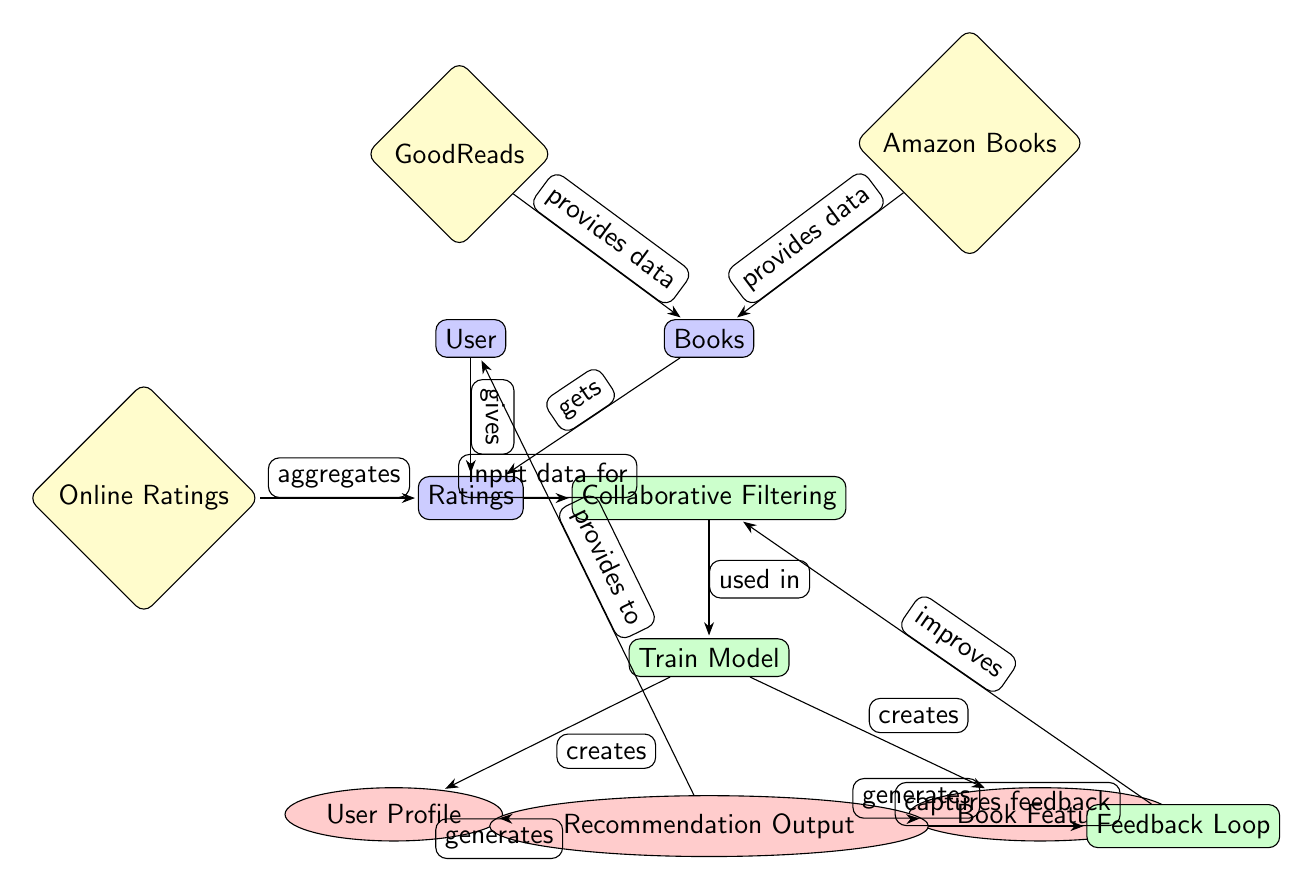What are the input data sources for the recommendation system? The diagram identifies two main data sources for the recommendation system: GoodReads and Amazon Books, which provide data to the "Books" node.
Answer: GoodReads, Amazon Books How many output nodes are present in the diagram? By counting the output nodes, we see three: User Profile, Book Features, and Recommendation Output.
Answer: 3 What is created from the training process? The training process, indicated by the "Train Model" node, creates both User Profile and Book Features as outputs.
Answer: User Profile, Book Features Which node captures feedback? The "Feedback Loop" node is responsible for capturing feedback from the "Recommendation Output" node.
Answer: Feedback Loop What is the relationship between Users and Ratings? The diagram shows a directional edge labeled "gives" from Users to Ratings, indicating that users provide ratings.
Answer: gives How does the feedback loop improve the collaborative filtering? The "Feedback Loop" captures feedback from the "Recommendation Output" and feeds it back to the "Collaborative Filtering" process to enhance its effectiveness.
Answer: improves What type of algorithm is applied in this recommendation system? The diagram specifies that "Collaborative Filtering" is the algorithm used for generating personalized reading recommendations.
Answer: Collaborative Filtering What data is aggregated to form Ratings? The "Online Ratings" node is defined as the source that aggregates data used to form the Ratings.
Answer: Online Ratings 